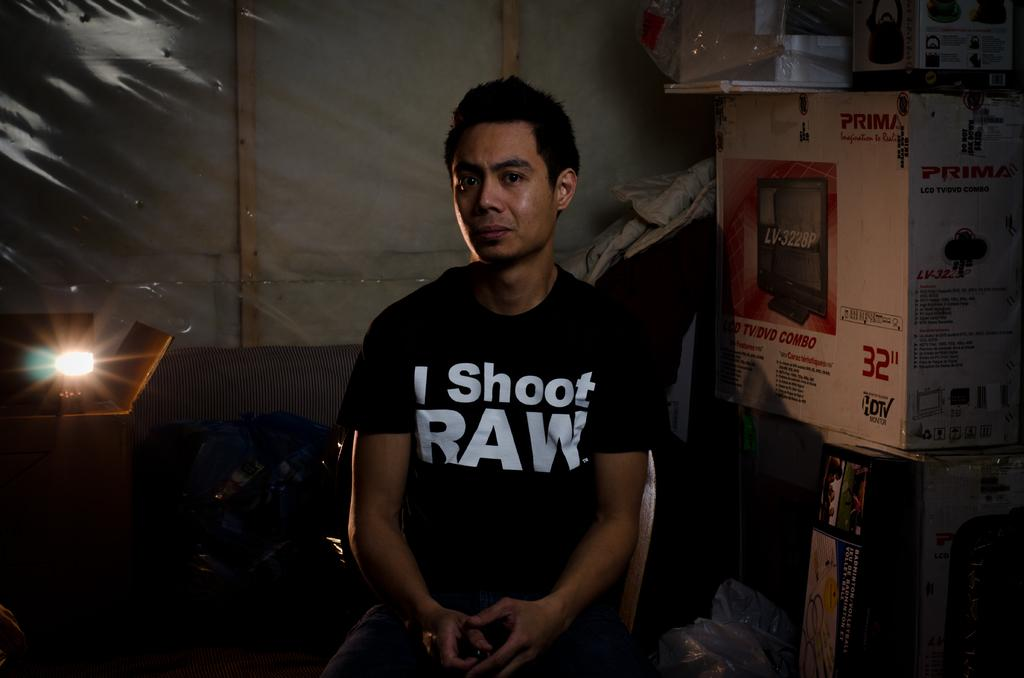What is the man in the image doing? The man is seated in the image. What is the man sitting on? The man is seated on a chair. What objects can be seen on the table in the image? There are carton boxes on a table in the image. What can be found on the left side of the image? There is a light on a table on the left side of the image. What type of cemetery can be seen in the background of the image? There is no cemetery present in the image; it features a man seated on a chair with carton boxes and a light on a table. 